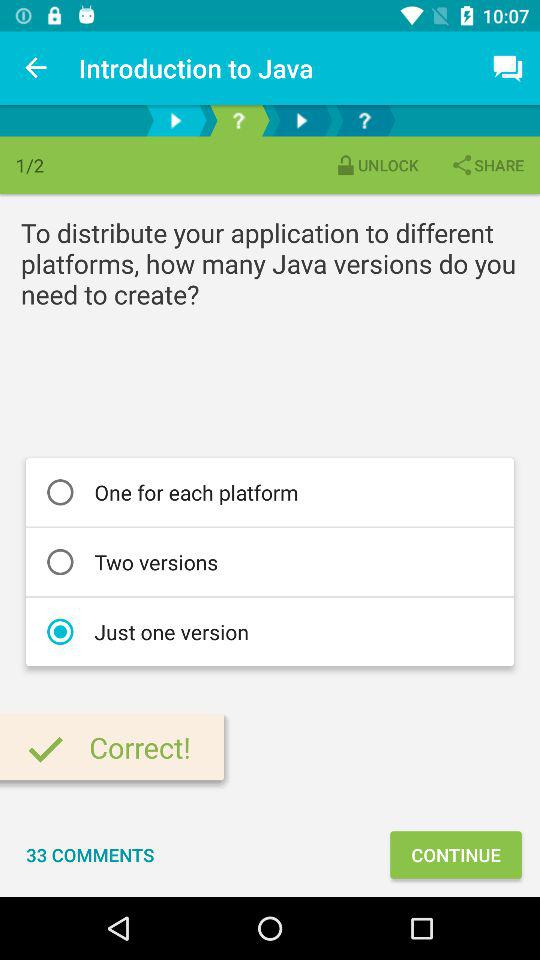How many options are there for the number of Java versions you need to create?
Answer the question using a single word or phrase. 3 